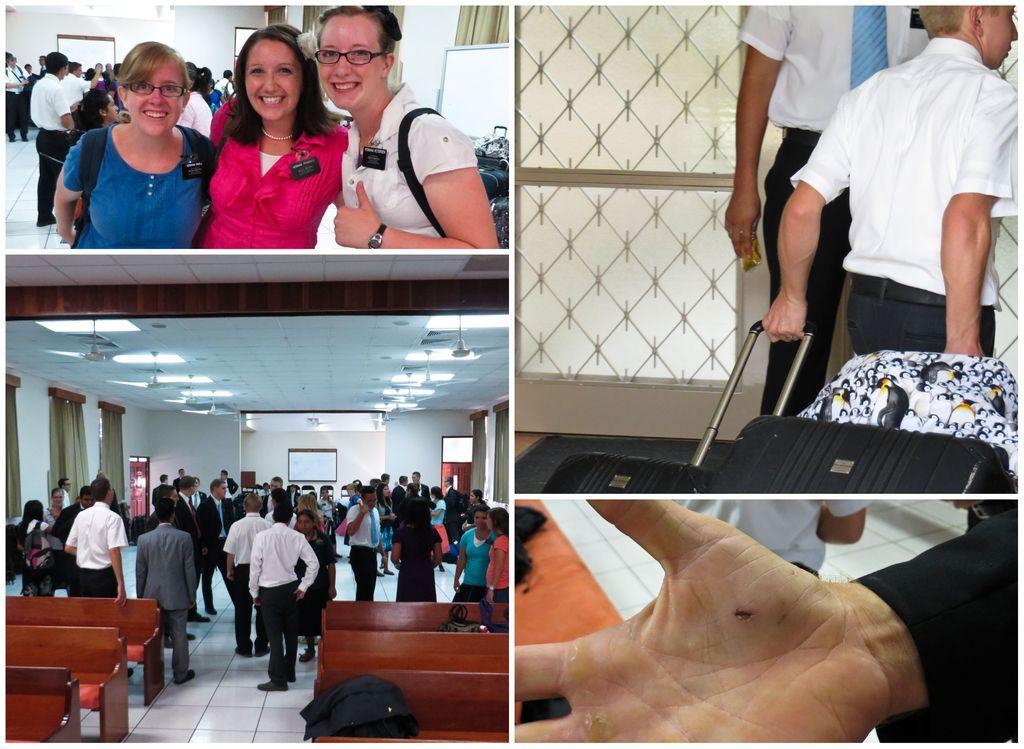In one or two sentences, can you explain what this image depicts? In this image we can see four pictures. In the first picture we can see these three women are standing and smiling. In the background, we can see a few more people. In the second picture we can see this person is holding the Trolley bags and in the background, we can see a person. In the third picture we can see these people standing on the floor, here we can see the wooden benches and in the background, we can see a few more things. In the fourth picture we can see a person's hand. 